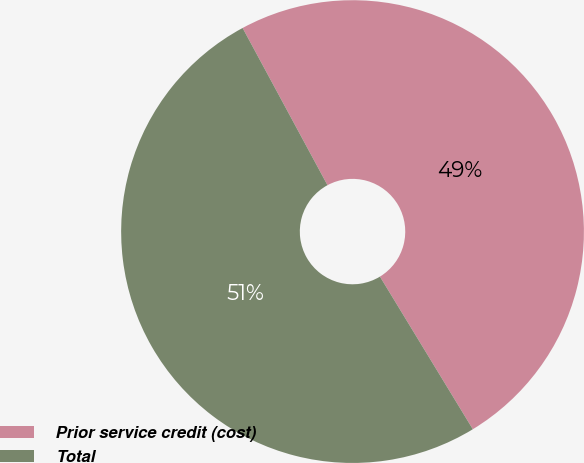<chart> <loc_0><loc_0><loc_500><loc_500><pie_chart><fcel>Prior service credit (cost)<fcel>Total<nl><fcel>49.18%<fcel>50.82%<nl></chart> 